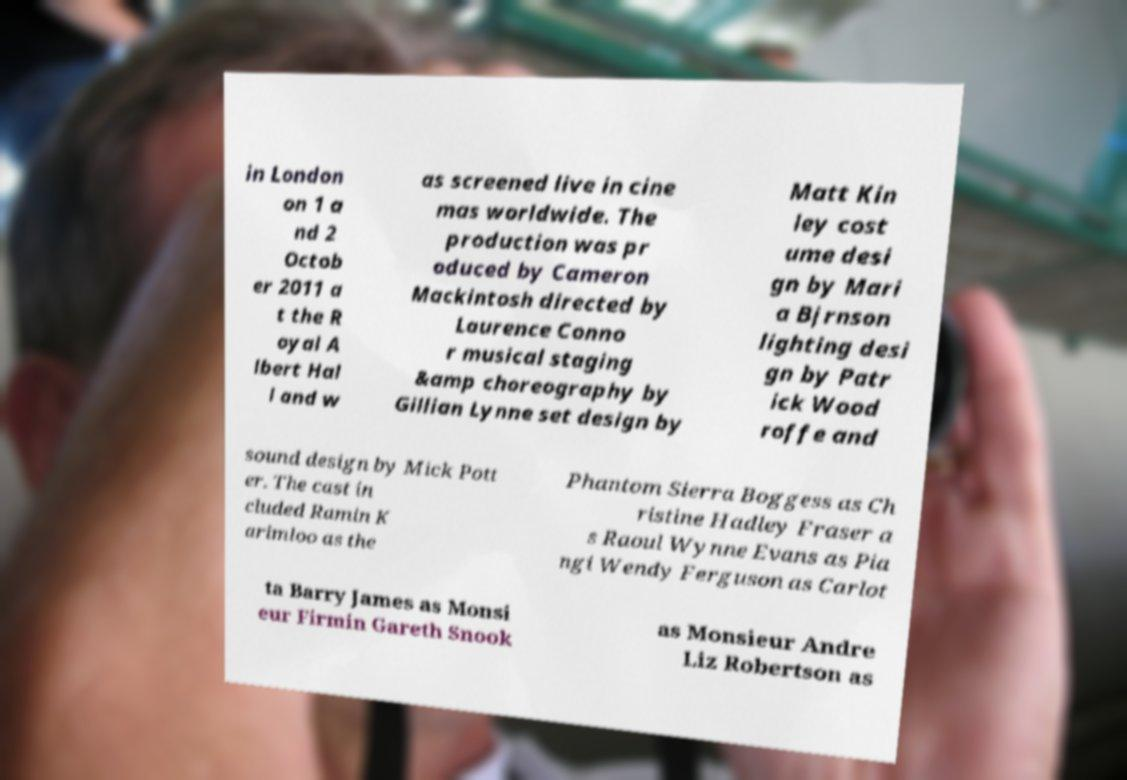I need the written content from this picture converted into text. Can you do that? in London on 1 a nd 2 Octob er 2011 a t the R oyal A lbert Hal l and w as screened live in cine mas worldwide. The production was pr oduced by Cameron Mackintosh directed by Laurence Conno r musical staging &amp choreography by Gillian Lynne set design by Matt Kin ley cost ume desi gn by Mari a Bjrnson lighting desi gn by Patr ick Wood roffe and sound design by Mick Pott er. The cast in cluded Ramin K arimloo as the Phantom Sierra Boggess as Ch ristine Hadley Fraser a s Raoul Wynne Evans as Pia ngi Wendy Ferguson as Carlot ta Barry James as Monsi eur Firmin Gareth Snook as Monsieur Andre Liz Robertson as 